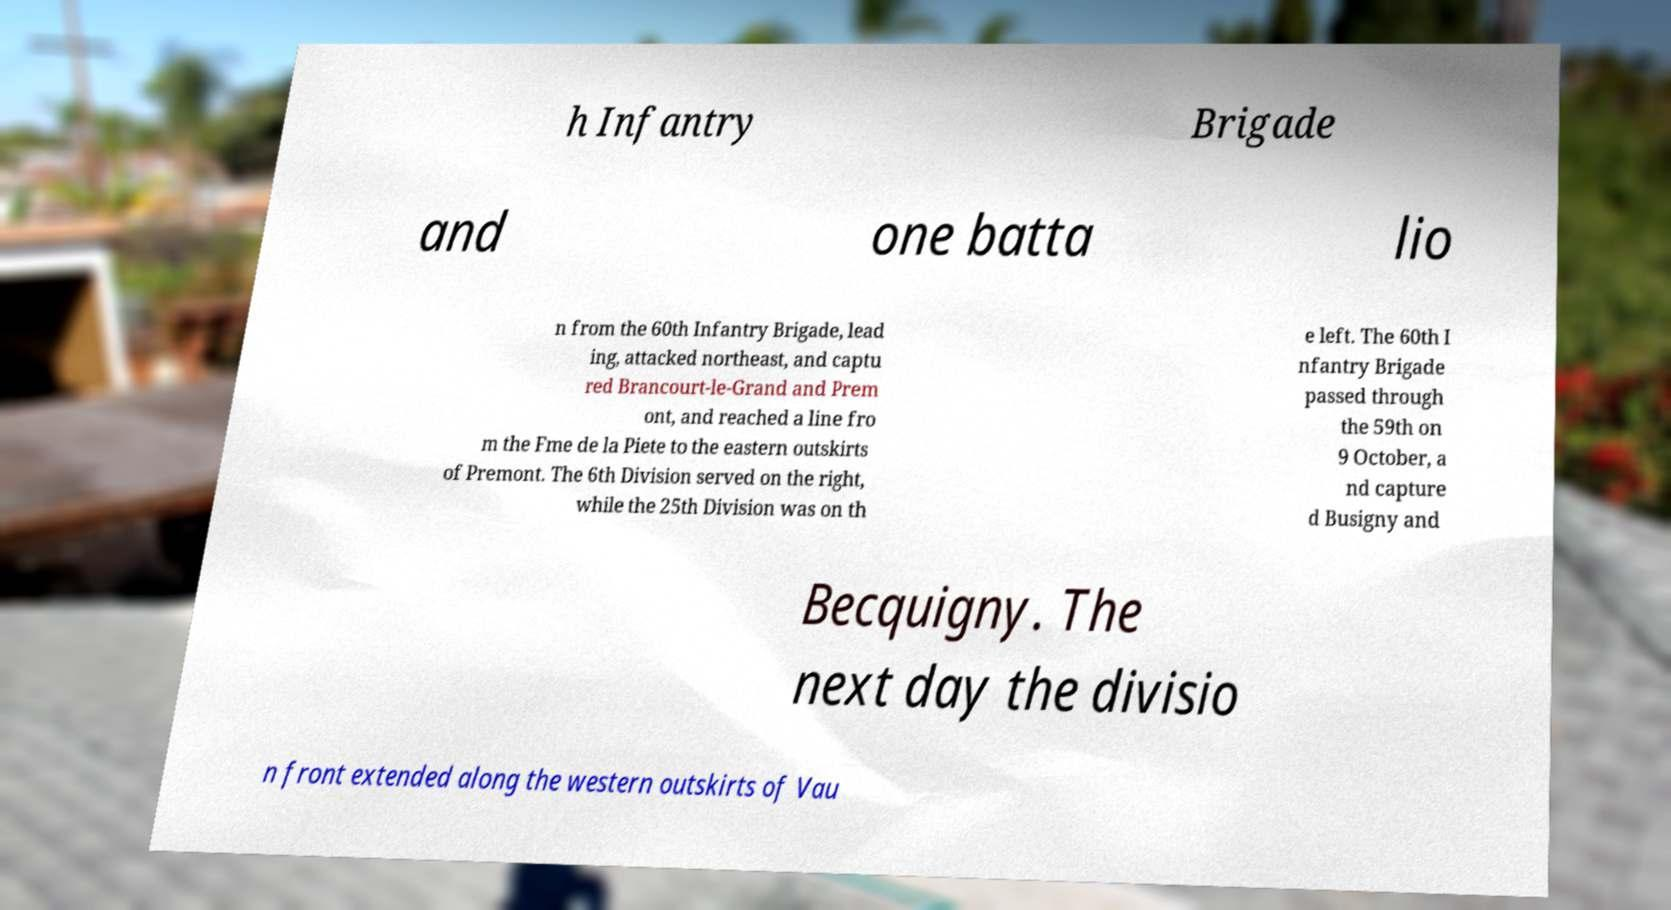Please identify and transcribe the text found in this image. h Infantry Brigade and one batta lio n from the 60th Infantry Brigade, lead ing, attacked northeast, and captu red Brancourt-le-Grand and Prem ont, and reached a line fro m the Fme de la Piete to the eastern outskirts of Premont. The 6th Division served on the right, while the 25th Division was on th e left. The 60th I nfantry Brigade passed through the 59th on 9 October, a nd capture d Busigny and Becquigny. The next day the divisio n front extended along the western outskirts of Vau 